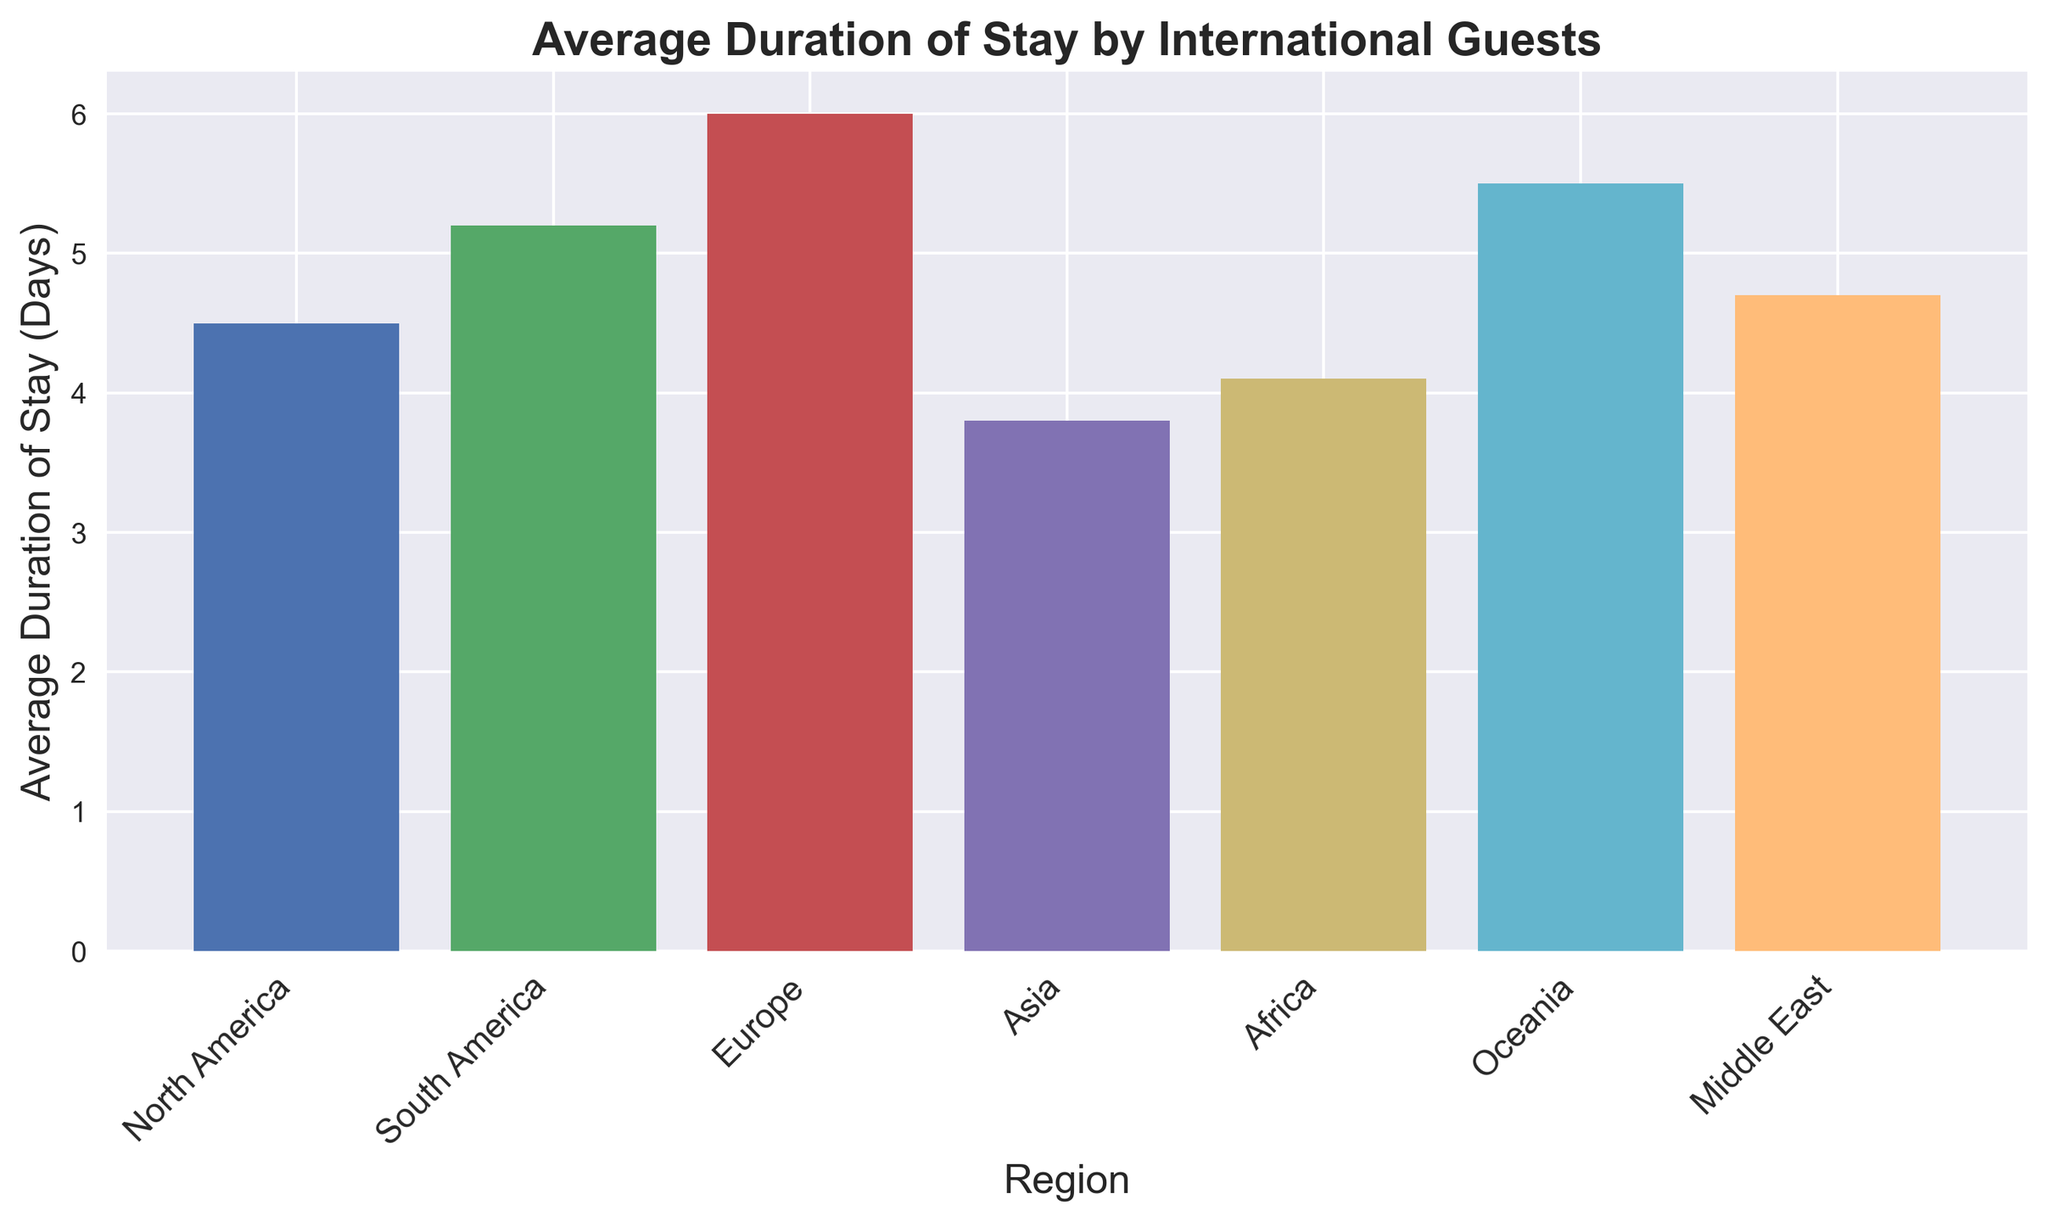Which region has the longest average duration of stay? The bar representing Europe is the tallest among the regions, indicating the longest average duration of stay.
Answer: Europe Which region has the shortest average duration of stay? The bar representing Asia is the shortest among the regions, indicating the shortest average duration of stay.
Answer: Asia How much longer is the average stay of guests from Europe compared to North America? The average stay for Europe is 6.0 days, while for North America it is 4.5 days. Subtracting the two values: 6.0 - 4.5 = 1.5 days.
Answer: 1.5 days Which two regions have the closest average duration of stay? The bars for North America (4.5 days) and Africa (4.1 days) are closest in height.
Answer: North America and Africa What is the average duration of stay across all regions? Sum up the average duration of stay for all regions: 4.5 + 5.2 + 6.0 + 3.8 + 4.1 + 5.5 + 4.7 = 33.8 days. Divide by the number of regions: 33.8 / 7 ≈ 4.83 days.
Answer: 4.83 days How much longer is the average stay of guests from Oceania compared to the Middle East? The average stay for Oceania is 5.5 days, while for the Middle East it is 4.7 days. Subtract the two values: 5.5 - 4.7 = 0.8 days.
Answer: 0.8 days Which region's bar is colored in purple? The bar representing the Middle East is colored in purple.
Answer: Middle East By how much does the average duration of stay in South America exceed that in Asia? The average stay for South America is 5.2 days, while for Asia it is 3.8 days. Subtract the two values: 5.2 - 3.8 = 1.4 days.
Answer: 1.4 days Rank the regions in descending order based on their average duration of stay. By comparing the heights of the bars: Europe (6.0), Oceania (5.5), South America (5.2), Middle East (4.7), North America (4.5), Africa (4.1), Asia (3.8)
Answer: Europe, Oceania, South America, Middle East, North America, Africa, Asia Does any region have an average stay duration exactly in the middle of the range covered? The range of stay durations is from 3.8 to 6.0 days. The middle value would be the median of the sorted durations: 3.8, 4.1, 4.5, 4.7, 5.2, 5.5, 6.0. The median is 4.7 days, which corresponds to the Middle East.
Answer: Middle East 